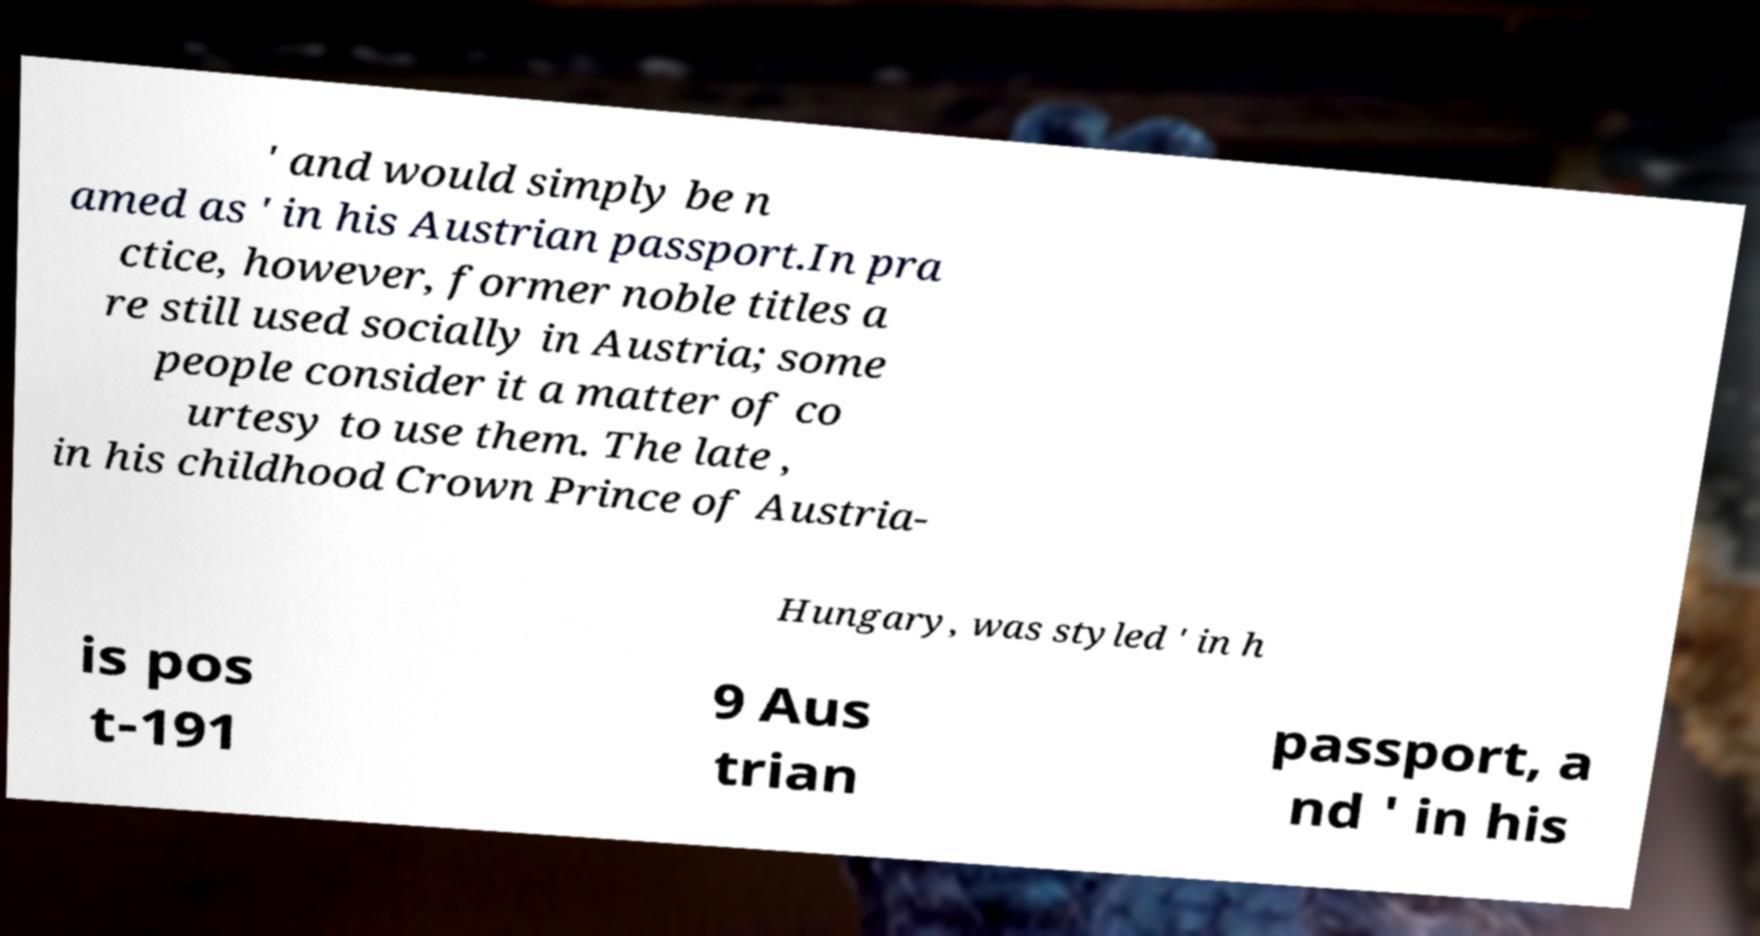I need the written content from this picture converted into text. Can you do that? ' and would simply be n amed as ' in his Austrian passport.In pra ctice, however, former noble titles a re still used socially in Austria; some people consider it a matter of co urtesy to use them. The late , in his childhood Crown Prince of Austria- Hungary, was styled ' in h is pos t-191 9 Aus trian passport, a nd ' in his 